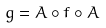<formula> <loc_0><loc_0><loc_500><loc_500>g = A \circ f \circ A</formula> 